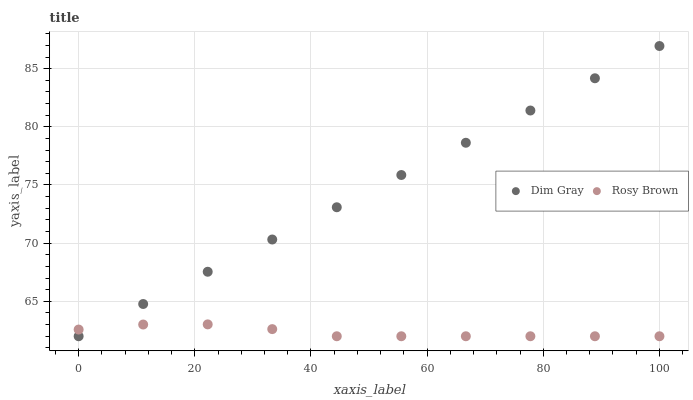Does Rosy Brown have the minimum area under the curve?
Answer yes or no. Yes. Does Dim Gray have the maximum area under the curve?
Answer yes or no. Yes. Does Dim Gray have the minimum area under the curve?
Answer yes or no. No. Is Dim Gray the smoothest?
Answer yes or no. Yes. Is Rosy Brown the roughest?
Answer yes or no. Yes. Is Dim Gray the roughest?
Answer yes or no. No. Does Rosy Brown have the lowest value?
Answer yes or no. Yes. Does Dim Gray have the highest value?
Answer yes or no. Yes. Does Rosy Brown intersect Dim Gray?
Answer yes or no. Yes. Is Rosy Brown less than Dim Gray?
Answer yes or no. No. Is Rosy Brown greater than Dim Gray?
Answer yes or no. No. 